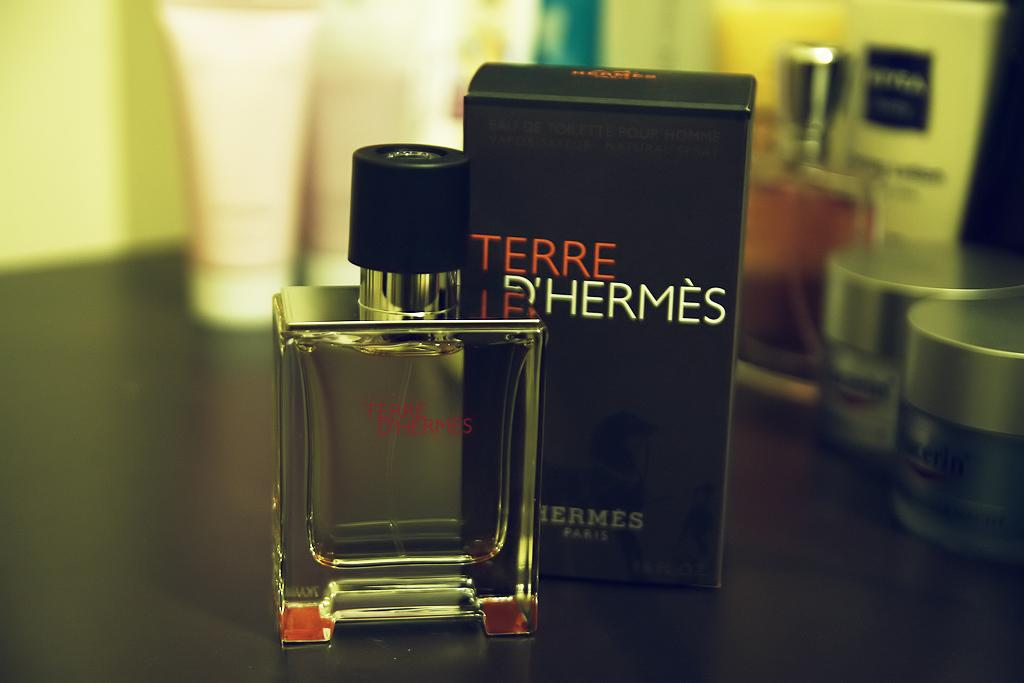What type of items can be seen on the table in the image? There are perfume bottles in the image. What else is present on the table besides the perfume bottles? There is a box and other objects on the table in the image. What type of soup is being served in the image? There is no soup present in the image; it features perfume bottles, a box, and other objects on a table. 